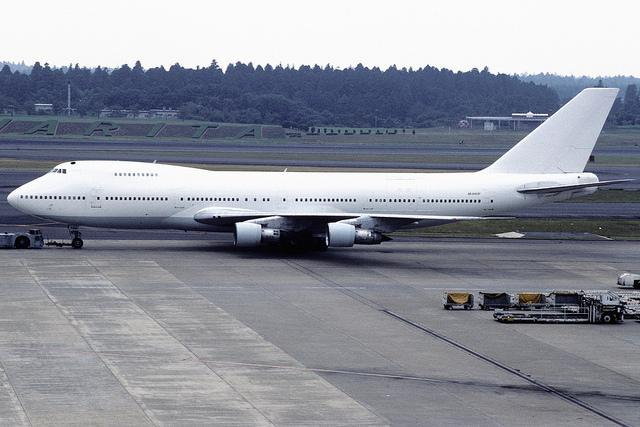Why is there no logo on the plane? Please explain your reasoning. not finished. The answer is unknowable from the image, but answer a is a reason that would cause logos and brands to be missing from objects that might normally have one. 